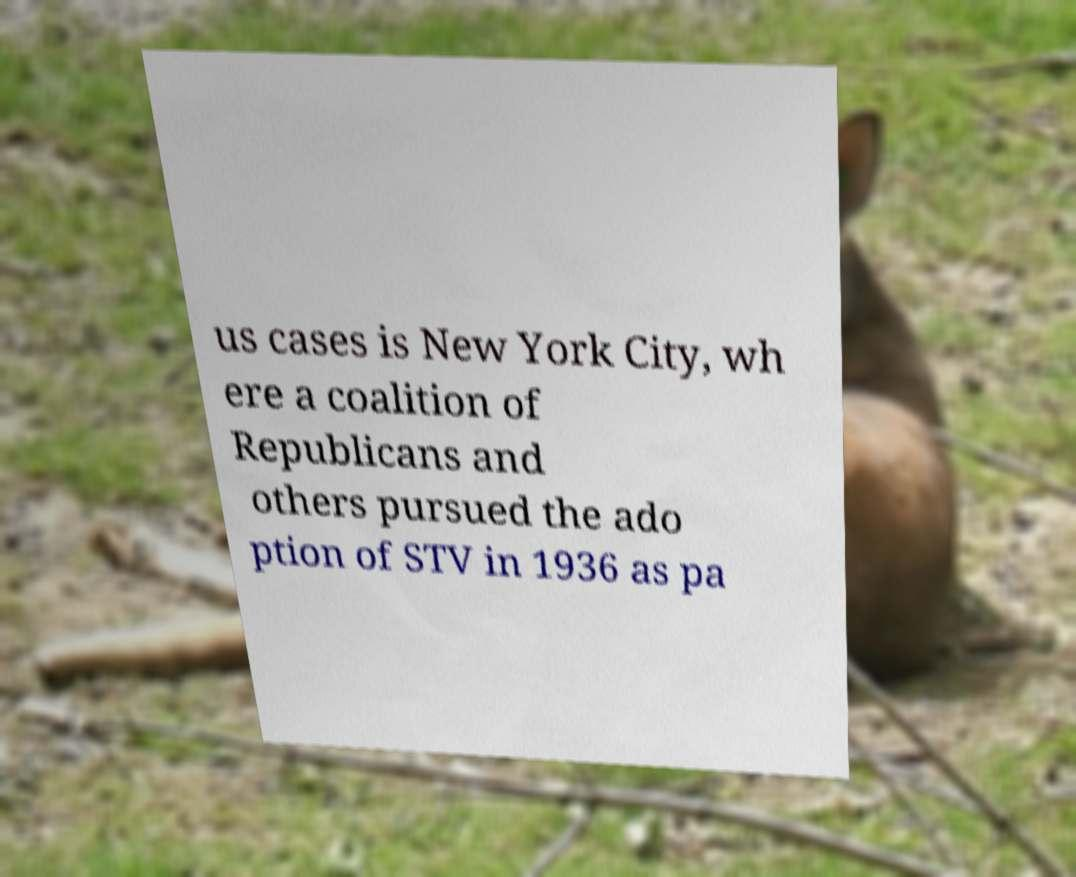What messages or text are displayed in this image? I need them in a readable, typed format. us cases is New York City, wh ere a coalition of Republicans and others pursued the ado ption of STV in 1936 as pa 